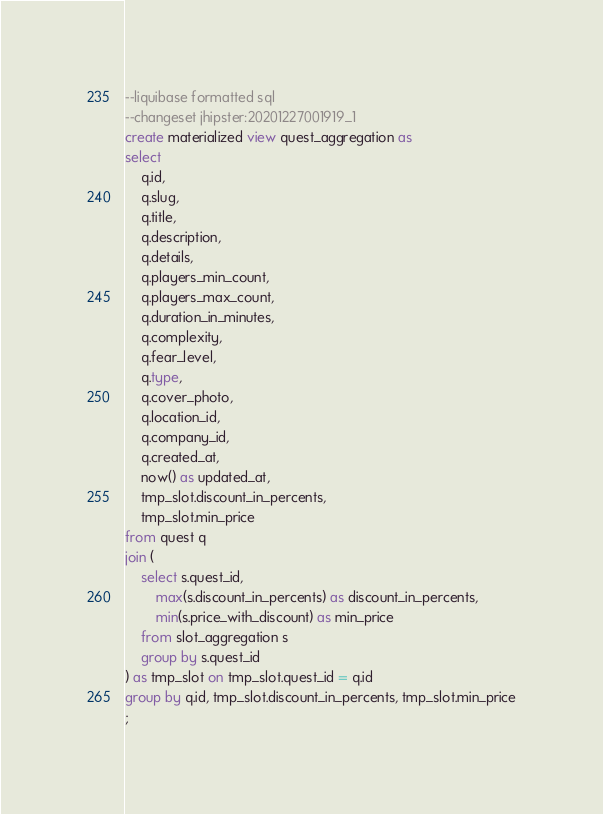<code> <loc_0><loc_0><loc_500><loc_500><_SQL_>--liquibase formatted sql
--changeset jhipster:20201227001919_1
create materialized view quest_aggregation as
select
    q.id,
    q.slug,
    q.title,
    q.description,
    q.details,
    q.players_min_count,
    q.players_max_count,
    q.duration_in_minutes,
    q.complexity,
    q.fear_level,
    q.type,
    q.cover_photo,
    q.location_id,
    q.company_id,
    q.created_at,
    now() as updated_at,
    tmp_slot.discount_in_percents,
    tmp_slot.min_price
from quest q
join (
    select s.quest_id,
        max(s.discount_in_percents) as discount_in_percents,
        min(s.price_with_discount) as min_price
    from slot_aggregation s
    group by s.quest_id
) as tmp_slot on tmp_slot.quest_id = q.id
group by q.id, tmp_slot.discount_in_percents, tmp_slot.min_price
;
</code> 